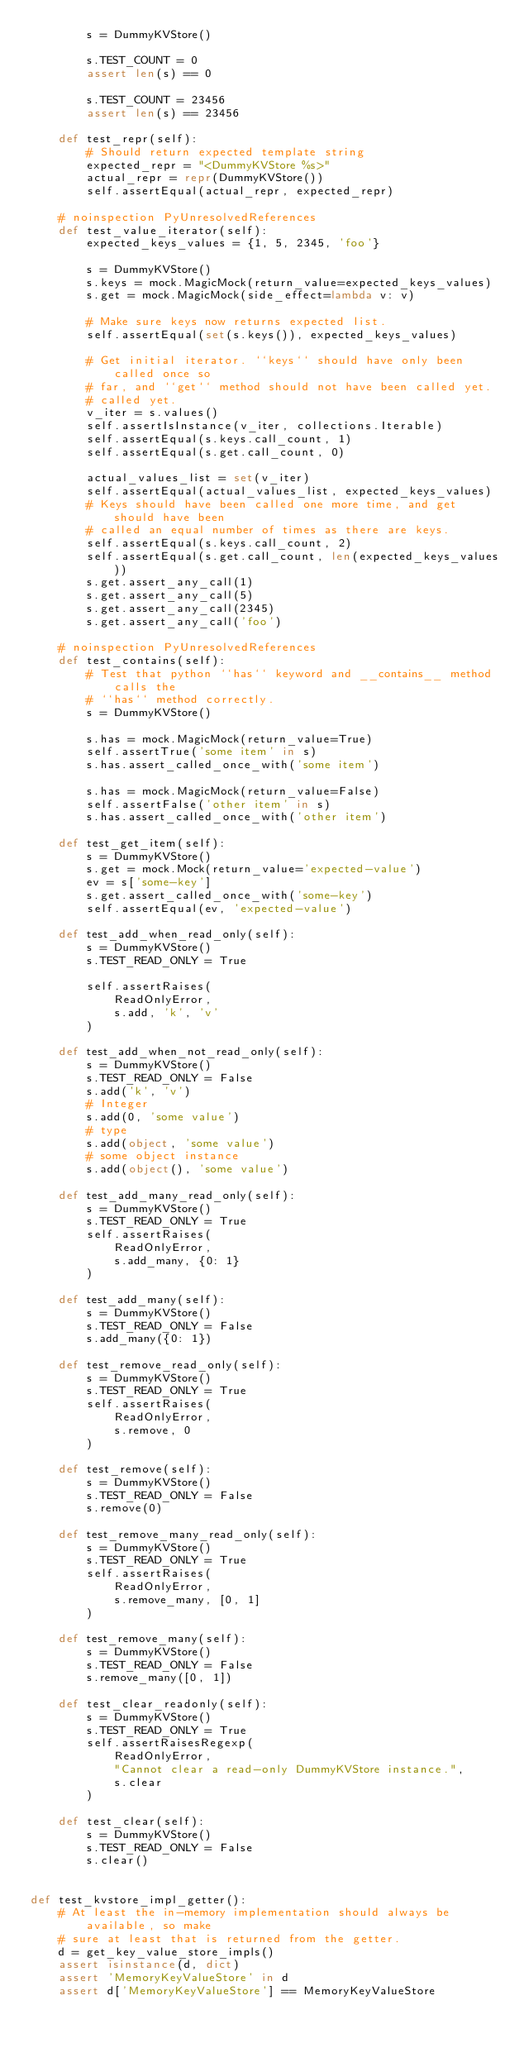Convert code to text. <code><loc_0><loc_0><loc_500><loc_500><_Python_>        s = DummyKVStore()

        s.TEST_COUNT = 0
        assert len(s) == 0

        s.TEST_COUNT = 23456
        assert len(s) == 23456

    def test_repr(self):
        # Should return expected template string
        expected_repr = "<DummyKVStore %s>"
        actual_repr = repr(DummyKVStore())
        self.assertEqual(actual_repr, expected_repr)

    # noinspection PyUnresolvedReferences
    def test_value_iterator(self):
        expected_keys_values = {1, 5, 2345, 'foo'}

        s = DummyKVStore()
        s.keys = mock.MagicMock(return_value=expected_keys_values)
        s.get = mock.MagicMock(side_effect=lambda v: v)

        # Make sure keys now returns expected list.
        self.assertEqual(set(s.keys()), expected_keys_values)

        # Get initial iterator. ``keys`` should have only been called once so
        # far, and ``get`` method should not have been called yet.
        # called yet.
        v_iter = s.values()
        self.assertIsInstance(v_iter, collections.Iterable)
        self.assertEqual(s.keys.call_count, 1)
        self.assertEqual(s.get.call_count, 0)

        actual_values_list = set(v_iter)
        self.assertEqual(actual_values_list, expected_keys_values)
        # Keys should have been called one more time, and get should have been
        # called an equal number of times as there are keys.
        self.assertEqual(s.keys.call_count, 2)
        self.assertEqual(s.get.call_count, len(expected_keys_values))
        s.get.assert_any_call(1)
        s.get.assert_any_call(5)
        s.get.assert_any_call(2345)
        s.get.assert_any_call('foo')

    # noinspection PyUnresolvedReferences
    def test_contains(self):
        # Test that python ``has`` keyword and __contains__ method calls the
        # ``has`` method correctly.
        s = DummyKVStore()

        s.has = mock.MagicMock(return_value=True)
        self.assertTrue('some item' in s)
        s.has.assert_called_once_with('some item')

        s.has = mock.MagicMock(return_value=False)
        self.assertFalse('other item' in s)
        s.has.assert_called_once_with('other item')

    def test_get_item(self):
        s = DummyKVStore()
        s.get = mock.Mock(return_value='expected-value')
        ev = s['some-key']
        s.get.assert_called_once_with('some-key')
        self.assertEqual(ev, 'expected-value')

    def test_add_when_read_only(self):
        s = DummyKVStore()
        s.TEST_READ_ONLY = True

        self.assertRaises(
            ReadOnlyError,
            s.add, 'k', 'v'
        )

    def test_add_when_not_read_only(self):
        s = DummyKVStore()
        s.TEST_READ_ONLY = False
        s.add('k', 'v')
        # Integer
        s.add(0, 'some value')
        # type
        s.add(object, 'some value')
        # some object instance
        s.add(object(), 'some value')

    def test_add_many_read_only(self):
        s = DummyKVStore()
        s.TEST_READ_ONLY = True
        self.assertRaises(
            ReadOnlyError,
            s.add_many, {0: 1}
        )

    def test_add_many(self):
        s = DummyKVStore()
        s.TEST_READ_ONLY = False
        s.add_many({0: 1})

    def test_remove_read_only(self):
        s = DummyKVStore()
        s.TEST_READ_ONLY = True
        self.assertRaises(
            ReadOnlyError,
            s.remove, 0
        )

    def test_remove(self):
        s = DummyKVStore()
        s.TEST_READ_ONLY = False
        s.remove(0)

    def test_remove_many_read_only(self):
        s = DummyKVStore()
        s.TEST_READ_ONLY = True
        self.assertRaises(
            ReadOnlyError,
            s.remove_many, [0, 1]
        )

    def test_remove_many(self):
        s = DummyKVStore()
        s.TEST_READ_ONLY = False
        s.remove_many([0, 1])

    def test_clear_readonly(self):
        s = DummyKVStore()
        s.TEST_READ_ONLY = True
        self.assertRaisesRegexp(
            ReadOnlyError,
            "Cannot clear a read-only DummyKVStore instance.",
            s.clear
        )

    def test_clear(self):
        s = DummyKVStore()
        s.TEST_READ_ONLY = False
        s.clear()


def test_kvstore_impl_getter():
    # At least the in-memory implementation should always be available, so make
    # sure at least that is returned from the getter.
    d = get_key_value_store_impls()
    assert isinstance(d, dict)
    assert 'MemoryKeyValueStore' in d
    assert d['MemoryKeyValueStore'] == MemoryKeyValueStore
</code> 